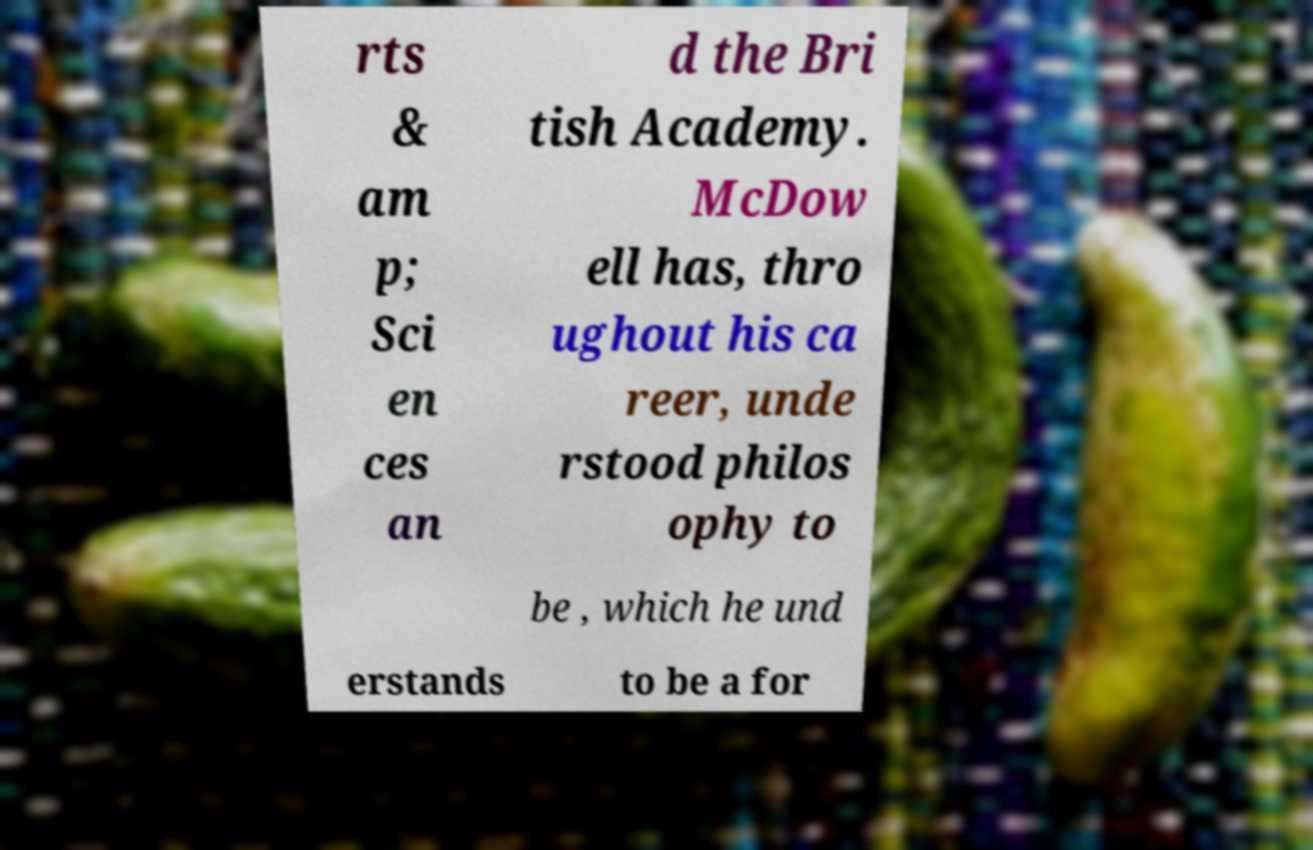Please identify and transcribe the text found in this image. rts & am p; Sci en ces an d the Bri tish Academy. McDow ell has, thro ughout his ca reer, unde rstood philos ophy to be , which he und erstands to be a for 